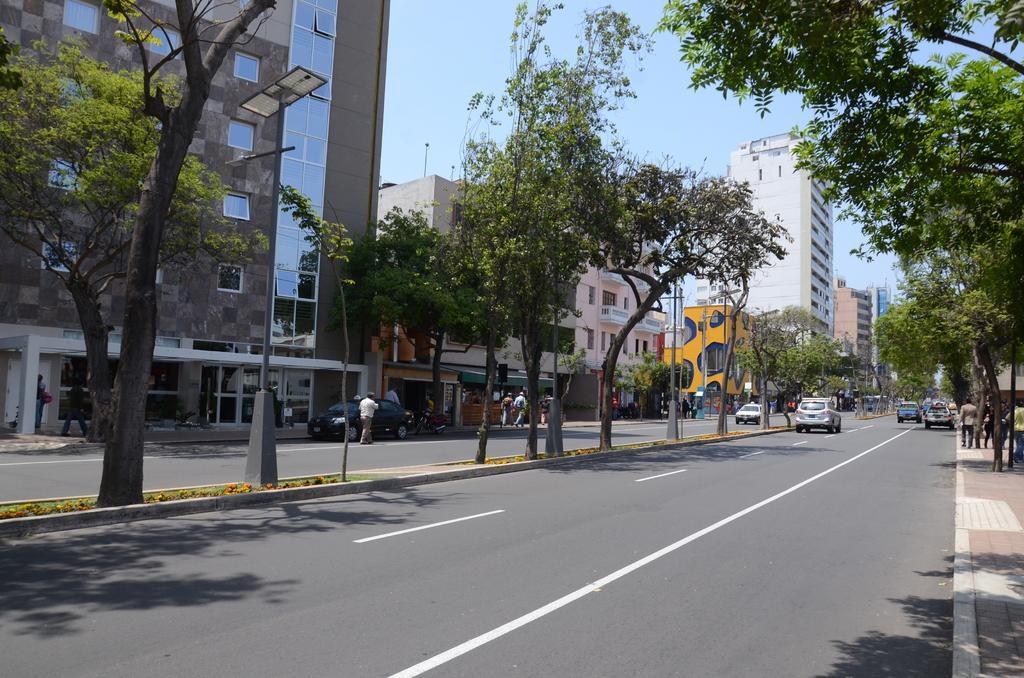In one or two sentences, can you explain what this image depicts? In this picture we can see few trees, poles, buildings and vehicles on the road, and also we can find group of people, few people are walking on the pathway, and also we can see few sign boards. 